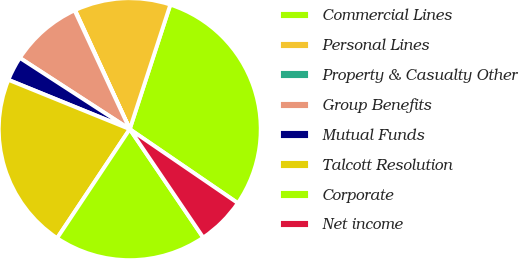<chart> <loc_0><loc_0><loc_500><loc_500><pie_chart><fcel>Commercial Lines<fcel>Personal Lines<fcel>Property & Casualty Other<fcel>Group Benefits<fcel>Mutual Funds<fcel>Talcott Resolution<fcel>Corporate<fcel>Net income<nl><fcel>29.53%<fcel>11.87%<fcel>0.07%<fcel>8.92%<fcel>3.01%<fcel>21.79%<fcel>18.84%<fcel>5.97%<nl></chart> 